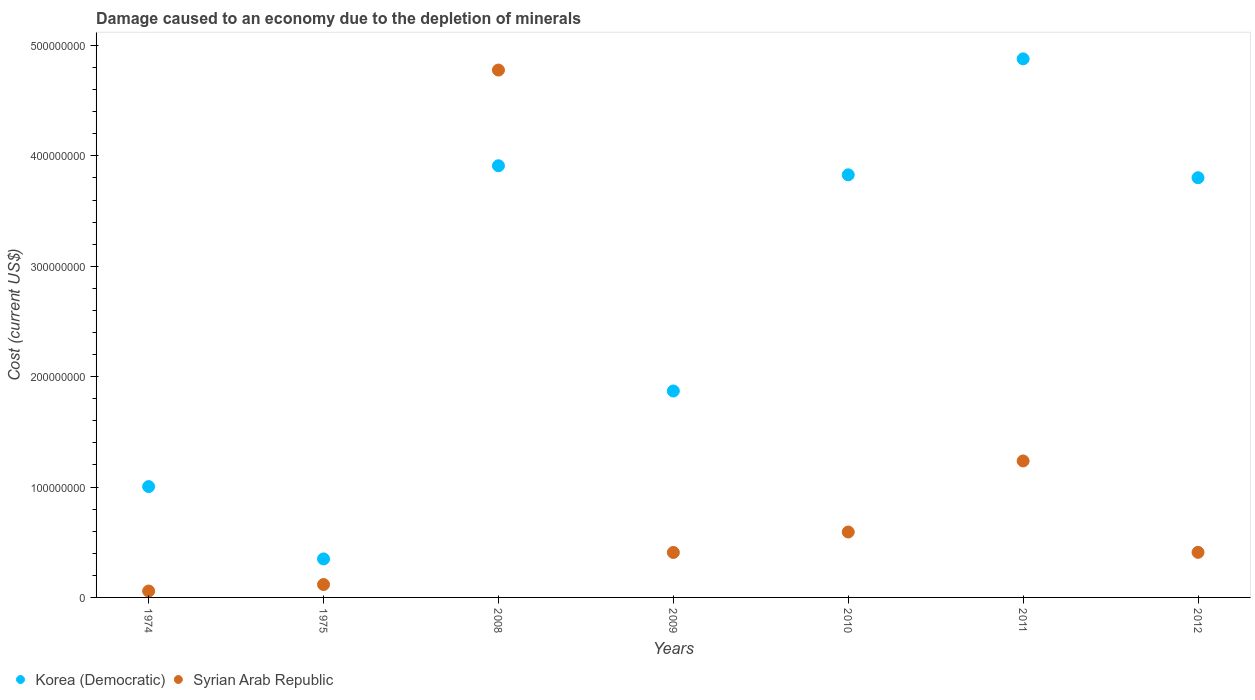How many different coloured dotlines are there?
Your answer should be compact. 2. Is the number of dotlines equal to the number of legend labels?
Provide a short and direct response. Yes. What is the cost of damage caused due to the depletion of minerals in Syrian Arab Republic in 2009?
Keep it short and to the point. 4.07e+07. Across all years, what is the maximum cost of damage caused due to the depletion of minerals in Korea (Democratic)?
Provide a short and direct response. 4.88e+08. Across all years, what is the minimum cost of damage caused due to the depletion of minerals in Syrian Arab Republic?
Give a very brief answer. 5.78e+06. In which year was the cost of damage caused due to the depletion of minerals in Syrian Arab Republic maximum?
Give a very brief answer. 2008. In which year was the cost of damage caused due to the depletion of minerals in Syrian Arab Republic minimum?
Your answer should be very brief. 1974. What is the total cost of damage caused due to the depletion of minerals in Syrian Arab Republic in the graph?
Your answer should be very brief. 7.60e+08. What is the difference between the cost of damage caused due to the depletion of minerals in Korea (Democratic) in 1974 and that in 2012?
Provide a short and direct response. -2.80e+08. What is the difference between the cost of damage caused due to the depletion of minerals in Syrian Arab Republic in 2010 and the cost of damage caused due to the depletion of minerals in Korea (Democratic) in 2008?
Your answer should be very brief. -3.32e+08. What is the average cost of damage caused due to the depletion of minerals in Korea (Democratic) per year?
Give a very brief answer. 2.81e+08. In the year 2009, what is the difference between the cost of damage caused due to the depletion of minerals in Syrian Arab Republic and cost of damage caused due to the depletion of minerals in Korea (Democratic)?
Provide a short and direct response. -1.46e+08. What is the ratio of the cost of damage caused due to the depletion of minerals in Korea (Democratic) in 2008 to that in 2012?
Your response must be concise. 1.03. Is the cost of damage caused due to the depletion of minerals in Korea (Democratic) in 2011 less than that in 2012?
Offer a very short reply. No. What is the difference between the highest and the second highest cost of damage caused due to the depletion of minerals in Korea (Democratic)?
Offer a terse response. 9.68e+07. What is the difference between the highest and the lowest cost of damage caused due to the depletion of minerals in Korea (Democratic)?
Offer a terse response. 4.53e+08. Is the sum of the cost of damage caused due to the depletion of minerals in Korea (Democratic) in 1974 and 2009 greater than the maximum cost of damage caused due to the depletion of minerals in Syrian Arab Republic across all years?
Keep it short and to the point. No. Is the cost of damage caused due to the depletion of minerals in Korea (Democratic) strictly less than the cost of damage caused due to the depletion of minerals in Syrian Arab Republic over the years?
Ensure brevity in your answer.  No. How many dotlines are there?
Offer a terse response. 2. What is the difference between two consecutive major ticks on the Y-axis?
Provide a succinct answer. 1.00e+08. Are the values on the major ticks of Y-axis written in scientific E-notation?
Provide a succinct answer. No. Does the graph contain any zero values?
Your answer should be compact. No. Where does the legend appear in the graph?
Provide a short and direct response. Bottom left. How many legend labels are there?
Give a very brief answer. 2. What is the title of the graph?
Your response must be concise. Damage caused to an economy due to the depletion of minerals. What is the label or title of the Y-axis?
Your answer should be very brief. Cost (current US$). What is the Cost (current US$) in Korea (Democratic) in 1974?
Your response must be concise. 1.00e+08. What is the Cost (current US$) of Syrian Arab Republic in 1974?
Your answer should be compact. 5.78e+06. What is the Cost (current US$) of Korea (Democratic) in 1975?
Offer a very short reply. 3.49e+07. What is the Cost (current US$) in Syrian Arab Republic in 1975?
Keep it short and to the point. 1.17e+07. What is the Cost (current US$) of Korea (Democratic) in 2008?
Offer a terse response. 3.91e+08. What is the Cost (current US$) in Syrian Arab Republic in 2008?
Provide a succinct answer. 4.78e+08. What is the Cost (current US$) of Korea (Democratic) in 2009?
Provide a short and direct response. 1.87e+08. What is the Cost (current US$) of Syrian Arab Republic in 2009?
Your response must be concise. 4.07e+07. What is the Cost (current US$) of Korea (Democratic) in 2010?
Ensure brevity in your answer.  3.83e+08. What is the Cost (current US$) of Syrian Arab Republic in 2010?
Your answer should be compact. 5.93e+07. What is the Cost (current US$) of Korea (Democratic) in 2011?
Your answer should be very brief. 4.88e+08. What is the Cost (current US$) in Syrian Arab Republic in 2011?
Give a very brief answer. 1.24e+08. What is the Cost (current US$) of Korea (Democratic) in 2012?
Keep it short and to the point. 3.80e+08. What is the Cost (current US$) in Syrian Arab Republic in 2012?
Your answer should be very brief. 4.09e+07. Across all years, what is the maximum Cost (current US$) in Korea (Democratic)?
Offer a terse response. 4.88e+08. Across all years, what is the maximum Cost (current US$) of Syrian Arab Republic?
Keep it short and to the point. 4.78e+08. Across all years, what is the minimum Cost (current US$) in Korea (Democratic)?
Provide a succinct answer. 3.49e+07. Across all years, what is the minimum Cost (current US$) of Syrian Arab Republic?
Offer a very short reply. 5.78e+06. What is the total Cost (current US$) in Korea (Democratic) in the graph?
Ensure brevity in your answer.  1.96e+09. What is the total Cost (current US$) in Syrian Arab Republic in the graph?
Ensure brevity in your answer.  7.60e+08. What is the difference between the Cost (current US$) in Korea (Democratic) in 1974 and that in 1975?
Provide a short and direct response. 6.55e+07. What is the difference between the Cost (current US$) of Syrian Arab Republic in 1974 and that in 1975?
Keep it short and to the point. -5.89e+06. What is the difference between the Cost (current US$) of Korea (Democratic) in 1974 and that in 2008?
Provide a succinct answer. -2.91e+08. What is the difference between the Cost (current US$) of Syrian Arab Republic in 1974 and that in 2008?
Make the answer very short. -4.72e+08. What is the difference between the Cost (current US$) of Korea (Democratic) in 1974 and that in 2009?
Keep it short and to the point. -8.66e+07. What is the difference between the Cost (current US$) of Syrian Arab Republic in 1974 and that in 2009?
Offer a very short reply. -3.50e+07. What is the difference between the Cost (current US$) of Korea (Democratic) in 1974 and that in 2010?
Make the answer very short. -2.82e+08. What is the difference between the Cost (current US$) of Syrian Arab Republic in 1974 and that in 2010?
Your answer should be very brief. -5.35e+07. What is the difference between the Cost (current US$) in Korea (Democratic) in 1974 and that in 2011?
Make the answer very short. -3.87e+08. What is the difference between the Cost (current US$) of Syrian Arab Republic in 1974 and that in 2011?
Offer a very short reply. -1.18e+08. What is the difference between the Cost (current US$) in Korea (Democratic) in 1974 and that in 2012?
Provide a succinct answer. -2.80e+08. What is the difference between the Cost (current US$) of Syrian Arab Republic in 1974 and that in 2012?
Your answer should be very brief. -3.51e+07. What is the difference between the Cost (current US$) of Korea (Democratic) in 1975 and that in 2008?
Your answer should be compact. -3.56e+08. What is the difference between the Cost (current US$) of Syrian Arab Republic in 1975 and that in 2008?
Provide a short and direct response. -4.66e+08. What is the difference between the Cost (current US$) in Korea (Democratic) in 1975 and that in 2009?
Provide a short and direct response. -1.52e+08. What is the difference between the Cost (current US$) of Syrian Arab Republic in 1975 and that in 2009?
Provide a succinct answer. -2.91e+07. What is the difference between the Cost (current US$) in Korea (Democratic) in 1975 and that in 2010?
Offer a very short reply. -3.48e+08. What is the difference between the Cost (current US$) in Syrian Arab Republic in 1975 and that in 2010?
Offer a very short reply. -4.76e+07. What is the difference between the Cost (current US$) in Korea (Democratic) in 1975 and that in 2011?
Make the answer very short. -4.53e+08. What is the difference between the Cost (current US$) in Syrian Arab Republic in 1975 and that in 2011?
Provide a short and direct response. -1.12e+08. What is the difference between the Cost (current US$) of Korea (Democratic) in 1975 and that in 2012?
Keep it short and to the point. -3.45e+08. What is the difference between the Cost (current US$) of Syrian Arab Republic in 1975 and that in 2012?
Make the answer very short. -2.92e+07. What is the difference between the Cost (current US$) in Korea (Democratic) in 2008 and that in 2009?
Offer a terse response. 2.04e+08. What is the difference between the Cost (current US$) in Syrian Arab Republic in 2008 and that in 2009?
Offer a terse response. 4.37e+08. What is the difference between the Cost (current US$) of Korea (Democratic) in 2008 and that in 2010?
Provide a short and direct response. 8.22e+06. What is the difference between the Cost (current US$) in Syrian Arab Republic in 2008 and that in 2010?
Ensure brevity in your answer.  4.18e+08. What is the difference between the Cost (current US$) in Korea (Democratic) in 2008 and that in 2011?
Ensure brevity in your answer.  -9.68e+07. What is the difference between the Cost (current US$) of Syrian Arab Republic in 2008 and that in 2011?
Keep it short and to the point. 3.54e+08. What is the difference between the Cost (current US$) of Korea (Democratic) in 2008 and that in 2012?
Give a very brief answer. 1.08e+07. What is the difference between the Cost (current US$) in Syrian Arab Republic in 2008 and that in 2012?
Provide a short and direct response. 4.37e+08. What is the difference between the Cost (current US$) in Korea (Democratic) in 2009 and that in 2010?
Ensure brevity in your answer.  -1.96e+08. What is the difference between the Cost (current US$) in Syrian Arab Republic in 2009 and that in 2010?
Provide a short and direct response. -1.85e+07. What is the difference between the Cost (current US$) of Korea (Democratic) in 2009 and that in 2011?
Provide a succinct answer. -3.01e+08. What is the difference between the Cost (current US$) of Syrian Arab Republic in 2009 and that in 2011?
Provide a short and direct response. -8.29e+07. What is the difference between the Cost (current US$) in Korea (Democratic) in 2009 and that in 2012?
Make the answer very short. -1.93e+08. What is the difference between the Cost (current US$) in Syrian Arab Republic in 2009 and that in 2012?
Your answer should be compact. -1.11e+05. What is the difference between the Cost (current US$) in Korea (Democratic) in 2010 and that in 2011?
Offer a very short reply. -1.05e+08. What is the difference between the Cost (current US$) in Syrian Arab Republic in 2010 and that in 2011?
Your answer should be compact. -6.44e+07. What is the difference between the Cost (current US$) in Korea (Democratic) in 2010 and that in 2012?
Offer a very short reply. 2.63e+06. What is the difference between the Cost (current US$) in Syrian Arab Republic in 2010 and that in 2012?
Your answer should be very brief. 1.84e+07. What is the difference between the Cost (current US$) in Korea (Democratic) in 2011 and that in 2012?
Offer a very short reply. 1.08e+08. What is the difference between the Cost (current US$) in Syrian Arab Republic in 2011 and that in 2012?
Offer a terse response. 8.28e+07. What is the difference between the Cost (current US$) of Korea (Democratic) in 1974 and the Cost (current US$) of Syrian Arab Republic in 1975?
Provide a short and direct response. 8.87e+07. What is the difference between the Cost (current US$) in Korea (Democratic) in 1974 and the Cost (current US$) in Syrian Arab Republic in 2008?
Provide a short and direct response. -3.77e+08. What is the difference between the Cost (current US$) in Korea (Democratic) in 1974 and the Cost (current US$) in Syrian Arab Republic in 2009?
Provide a succinct answer. 5.97e+07. What is the difference between the Cost (current US$) in Korea (Democratic) in 1974 and the Cost (current US$) in Syrian Arab Republic in 2010?
Give a very brief answer. 4.12e+07. What is the difference between the Cost (current US$) of Korea (Democratic) in 1974 and the Cost (current US$) of Syrian Arab Republic in 2011?
Keep it short and to the point. -2.32e+07. What is the difference between the Cost (current US$) in Korea (Democratic) in 1974 and the Cost (current US$) in Syrian Arab Republic in 2012?
Your answer should be compact. 5.96e+07. What is the difference between the Cost (current US$) of Korea (Democratic) in 1975 and the Cost (current US$) of Syrian Arab Republic in 2008?
Your response must be concise. -4.43e+08. What is the difference between the Cost (current US$) of Korea (Democratic) in 1975 and the Cost (current US$) of Syrian Arab Republic in 2009?
Make the answer very short. -5.86e+06. What is the difference between the Cost (current US$) in Korea (Democratic) in 1975 and the Cost (current US$) in Syrian Arab Republic in 2010?
Your answer should be very brief. -2.44e+07. What is the difference between the Cost (current US$) of Korea (Democratic) in 1975 and the Cost (current US$) of Syrian Arab Republic in 2011?
Ensure brevity in your answer.  -8.88e+07. What is the difference between the Cost (current US$) in Korea (Democratic) in 1975 and the Cost (current US$) in Syrian Arab Republic in 2012?
Offer a very short reply. -5.97e+06. What is the difference between the Cost (current US$) of Korea (Democratic) in 2008 and the Cost (current US$) of Syrian Arab Republic in 2009?
Give a very brief answer. 3.50e+08. What is the difference between the Cost (current US$) in Korea (Democratic) in 2008 and the Cost (current US$) in Syrian Arab Republic in 2010?
Keep it short and to the point. 3.32e+08. What is the difference between the Cost (current US$) in Korea (Democratic) in 2008 and the Cost (current US$) in Syrian Arab Republic in 2011?
Make the answer very short. 2.67e+08. What is the difference between the Cost (current US$) in Korea (Democratic) in 2008 and the Cost (current US$) in Syrian Arab Republic in 2012?
Your answer should be compact. 3.50e+08. What is the difference between the Cost (current US$) of Korea (Democratic) in 2009 and the Cost (current US$) of Syrian Arab Republic in 2010?
Ensure brevity in your answer.  1.28e+08. What is the difference between the Cost (current US$) in Korea (Democratic) in 2009 and the Cost (current US$) in Syrian Arab Republic in 2011?
Provide a short and direct response. 6.34e+07. What is the difference between the Cost (current US$) of Korea (Democratic) in 2009 and the Cost (current US$) of Syrian Arab Republic in 2012?
Give a very brief answer. 1.46e+08. What is the difference between the Cost (current US$) of Korea (Democratic) in 2010 and the Cost (current US$) of Syrian Arab Republic in 2011?
Provide a succinct answer. 2.59e+08. What is the difference between the Cost (current US$) in Korea (Democratic) in 2010 and the Cost (current US$) in Syrian Arab Republic in 2012?
Offer a terse response. 3.42e+08. What is the difference between the Cost (current US$) in Korea (Democratic) in 2011 and the Cost (current US$) in Syrian Arab Republic in 2012?
Keep it short and to the point. 4.47e+08. What is the average Cost (current US$) in Korea (Democratic) per year?
Offer a terse response. 2.81e+08. What is the average Cost (current US$) of Syrian Arab Republic per year?
Your answer should be very brief. 1.09e+08. In the year 1974, what is the difference between the Cost (current US$) of Korea (Democratic) and Cost (current US$) of Syrian Arab Republic?
Provide a succinct answer. 9.46e+07. In the year 1975, what is the difference between the Cost (current US$) in Korea (Democratic) and Cost (current US$) in Syrian Arab Republic?
Offer a very short reply. 2.32e+07. In the year 2008, what is the difference between the Cost (current US$) in Korea (Democratic) and Cost (current US$) in Syrian Arab Republic?
Provide a succinct answer. -8.67e+07. In the year 2009, what is the difference between the Cost (current US$) in Korea (Democratic) and Cost (current US$) in Syrian Arab Republic?
Make the answer very short. 1.46e+08. In the year 2010, what is the difference between the Cost (current US$) of Korea (Democratic) and Cost (current US$) of Syrian Arab Republic?
Your answer should be compact. 3.24e+08. In the year 2011, what is the difference between the Cost (current US$) in Korea (Democratic) and Cost (current US$) in Syrian Arab Republic?
Provide a short and direct response. 3.64e+08. In the year 2012, what is the difference between the Cost (current US$) of Korea (Democratic) and Cost (current US$) of Syrian Arab Republic?
Ensure brevity in your answer.  3.39e+08. What is the ratio of the Cost (current US$) in Korea (Democratic) in 1974 to that in 1975?
Your answer should be compact. 2.88. What is the ratio of the Cost (current US$) in Syrian Arab Republic in 1974 to that in 1975?
Keep it short and to the point. 0.5. What is the ratio of the Cost (current US$) of Korea (Democratic) in 1974 to that in 2008?
Offer a terse response. 0.26. What is the ratio of the Cost (current US$) of Syrian Arab Republic in 1974 to that in 2008?
Offer a terse response. 0.01. What is the ratio of the Cost (current US$) of Korea (Democratic) in 1974 to that in 2009?
Your answer should be very brief. 0.54. What is the ratio of the Cost (current US$) in Syrian Arab Republic in 1974 to that in 2009?
Keep it short and to the point. 0.14. What is the ratio of the Cost (current US$) in Korea (Democratic) in 1974 to that in 2010?
Provide a short and direct response. 0.26. What is the ratio of the Cost (current US$) of Syrian Arab Republic in 1974 to that in 2010?
Provide a succinct answer. 0.1. What is the ratio of the Cost (current US$) of Korea (Democratic) in 1974 to that in 2011?
Offer a terse response. 0.21. What is the ratio of the Cost (current US$) of Syrian Arab Republic in 1974 to that in 2011?
Your answer should be very brief. 0.05. What is the ratio of the Cost (current US$) of Korea (Democratic) in 1974 to that in 2012?
Give a very brief answer. 0.26. What is the ratio of the Cost (current US$) of Syrian Arab Republic in 1974 to that in 2012?
Your response must be concise. 0.14. What is the ratio of the Cost (current US$) in Korea (Democratic) in 1975 to that in 2008?
Keep it short and to the point. 0.09. What is the ratio of the Cost (current US$) in Syrian Arab Republic in 1975 to that in 2008?
Your answer should be compact. 0.02. What is the ratio of the Cost (current US$) in Korea (Democratic) in 1975 to that in 2009?
Your answer should be compact. 0.19. What is the ratio of the Cost (current US$) in Syrian Arab Republic in 1975 to that in 2009?
Offer a terse response. 0.29. What is the ratio of the Cost (current US$) of Korea (Democratic) in 1975 to that in 2010?
Your answer should be very brief. 0.09. What is the ratio of the Cost (current US$) of Syrian Arab Republic in 1975 to that in 2010?
Your response must be concise. 0.2. What is the ratio of the Cost (current US$) of Korea (Democratic) in 1975 to that in 2011?
Offer a very short reply. 0.07. What is the ratio of the Cost (current US$) of Syrian Arab Republic in 1975 to that in 2011?
Offer a terse response. 0.09. What is the ratio of the Cost (current US$) in Korea (Democratic) in 1975 to that in 2012?
Make the answer very short. 0.09. What is the ratio of the Cost (current US$) in Syrian Arab Republic in 1975 to that in 2012?
Offer a terse response. 0.29. What is the ratio of the Cost (current US$) of Korea (Democratic) in 2008 to that in 2009?
Keep it short and to the point. 2.09. What is the ratio of the Cost (current US$) in Syrian Arab Republic in 2008 to that in 2009?
Provide a short and direct response. 11.73. What is the ratio of the Cost (current US$) of Korea (Democratic) in 2008 to that in 2010?
Offer a very short reply. 1.02. What is the ratio of the Cost (current US$) of Syrian Arab Republic in 2008 to that in 2010?
Your response must be concise. 8.06. What is the ratio of the Cost (current US$) of Korea (Democratic) in 2008 to that in 2011?
Give a very brief answer. 0.8. What is the ratio of the Cost (current US$) of Syrian Arab Republic in 2008 to that in 2011?
Your answer should be compact. 3.86. What is the ratio of the Cost (current US$) in Korea (Democratic) in 2008 to that in 2012?
Provide a succinct answer. 1.03. What is the ratio of the Cost (current US$) of Syrian Arab Republic in 2008 to that in 2012?
Give a very brief answer. 11.69. What is the ratio of the Cost (current US$) in Korea (Democratic) in 2009 to that in 2010?
Provide a succinct answer. 0.49. What is the ratio of the Cost (current US$) of Syrian Arab Republic in 2009 to that in 2010?
Your response must be concise. 0.69. What is the ratio of the Cost (current US$) in Korea (Democratic) in 2009 to that in 2011?
Give a very brief answer. 0.38. What is the ratio of the Cost (current US$) in Syrian Arab Republic in 2009 to that in 2011?
Provide a succinct answer. 0.33. What is the ratio of the Cost (current US$) of Korea (Democratic) in 2009 to that in 2012?
Your response must be concise. 0.49. What is the ratio of the Cost (current US$) of Korea (Democratic) in 2010 to that in 2011?
Your response must be concise. 0.78. What is the ratio of the Cost (current US$) of Syrian Arab Republic in 2010 to that in 2011?
Give a very brief answer. 0.48. What is the ratio of the Cost (current US$) of Syrian Arab Republic in 2010 to that in 2012?
Provide a succinct answer. 1.45. What is the ratio of the Cost (current US$) in Korea (Democratic) in 2011 to that in 2012?
Offer a terse response. 1.28. What is the ratio of the Cost (current US$) of Syrian Arab Republic in 2011 to that in 2012?
Your answer should be compact. 3.03. What is the difference between the highest and the second highest Cost (current US$) in Korea (Democratic)?
Offer a very short reply. 9.68e+07. What is the difference between the highest and the second highest Cost (current US$) of Syrian Arab Republic?
Your response must be concise. 3.54e+08. What is the difference between the highest and the lowest Cost (current US$) of Korea (Democratic)?
Your answer should be very brief. 4.53e+08. What is the difference between the highest and the lowest Cost (current US$) of Syrian Arab Republic?
Offer a terse response. 4.72e+08. 